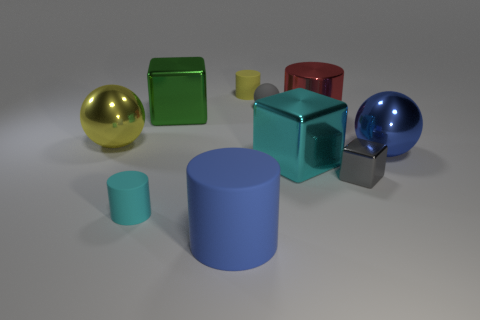Does the big red shiny object have the same shape as the small cyan thing?
Offer a terse response. Yes. There is a gray matte object that is the same shape as the yellow metallic object; what is its size?
Keep it short and to the point. Small. How big is the thing that is behind the big red object and to the left of the blue matte cylinder?
Provide a short and direct response. Large. How many metallic things are either small gray cylinders or spheres?
Make the answer very short. 2. What is the big yellow ball made of?
Ensure brevity in your answer.  Metal. What material is the small gray object behind the large metallic cube that is to the left of the cyan object right of the small cyan rubber object made of?
Provide a succinct answer. Rubber. There is a green thing that is the same size as the cyan metallic object; what is its shape?
Your answer should be compact. Cube. What number of things are small cyan rubber objects or matte objects behind the blue rubber cylinder?
Your answer should be very brief. 3. Is the material of the large sphere that is on the right side of the cyan rubber thing the same as the gray thing that is behind the large red metal cylinder?
Keep it short and to the point. No. There is a small thing that is the same color as the tiny block; what shape is it?
Provide a short and direct response. Sphere. 